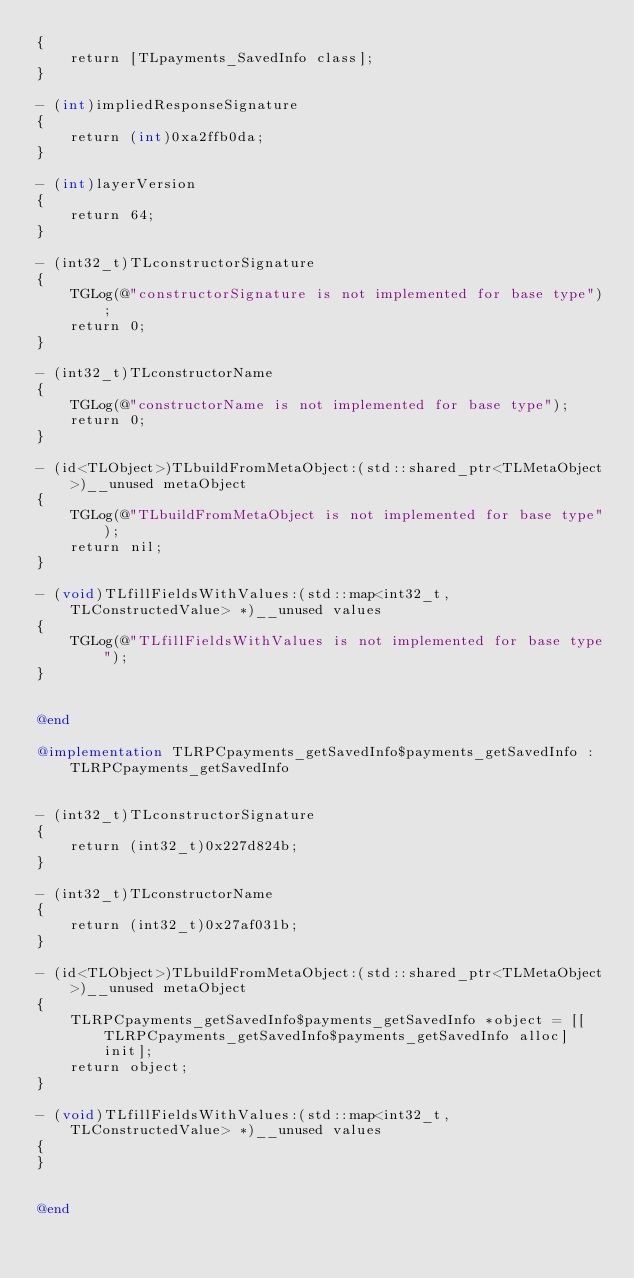<code> <loc_0><loc_0><loc_500><loc_500><_ObjectiveC_>{
    return [TLpayments_SavedInfo class];
}

- (int)impliedResponseSignature
{
    return (int)0xa2ffb0da;
}

- (int)layerVersion
{
    return 64;
}

- (int32_t)TLconstructorSignature
{
    TGLog(@"constructorSignature is not implemented for base type");
    return 0;
}

- (int32_t)TLconstructorName
{
    TGLog(@"constructorName is not implemented for base type");
    return 0;
}

- (id<TLObject>)TLbuildFromMetaObject:(std::shared_ptr<TLMetaObject>)__unused metaObject
{
    TGLog(@"TLbuildFromMetaObject is not implemented for base type");
    return nil;
}

- (void)TLfillFieldsWithValues:(std::map<int32_t, TLConstructedValue> *)__unused values
{
    TGLog(@"TLfillFieldsWithValues is not implemented for base type");
}


@end

@implementation TLRPCpayments_getSavedInfo$payments_getSavedInfo : TLRPCpayments_getSavedInfo


- (int32_t)TLconstructorSignature
{
    return (int32_t)0x227d824b;
}

- (int32_t)TLconstructorName
{
    return (int32_t)0x27af031b;
}

- (id<TLObject>)TLbuildFromMetaObject:(std::shared_ptr<TLMetaObject>)__unused metaObject
{
    TLRPCpayments_getSavedInfo$payments_getSavedInfo *object = [[TLRPCpayments_getSavedInfo$payments_getSavedInfo alloc] init];
    return object;
}

- (void)TLfillFieldsWithValues:(std::map<int32_t, TLConstructedValue> *)__unused values
{
}


@end

</code> 